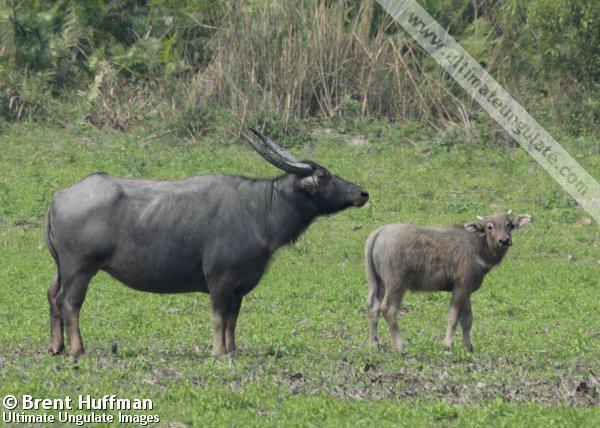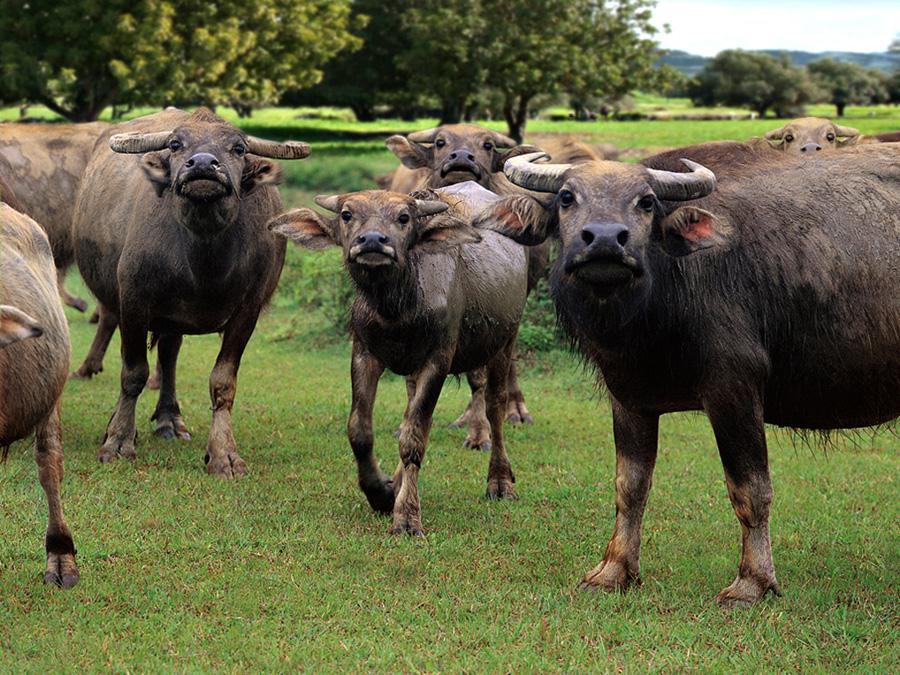The first image is the image on the left, the second image is the image on the right. For the images shown, is this caption "One of the images contains exactly two steer" true? Answer yes or no. Yes. The first image is the image on the left, the second image is the image on the right. For the images shown, is this caption "Exactly two hooved animals are shown in one image." true? Answer yes or no. Yes. 